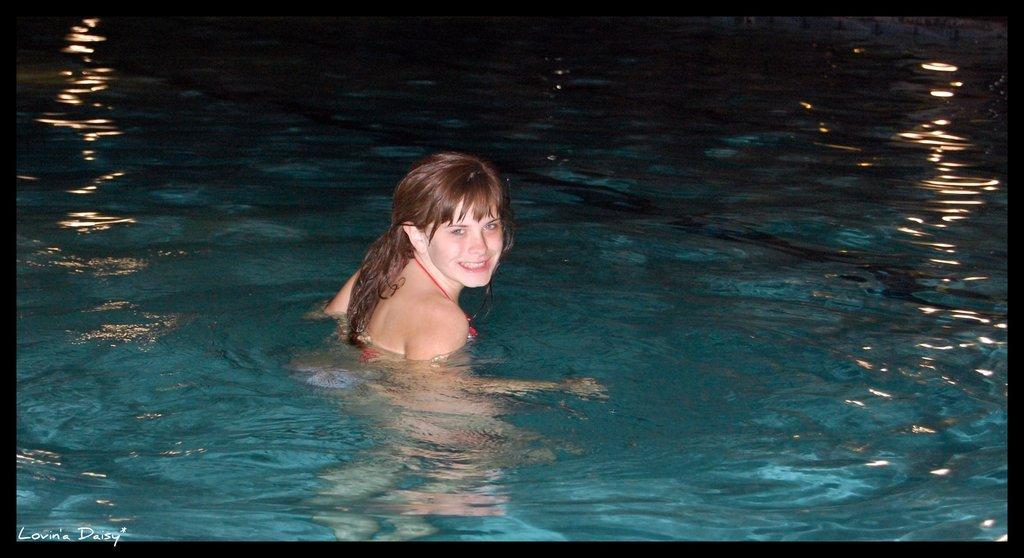How would you summarize this image in a sentence or two? In this image we can see a woman swimming in the water. 